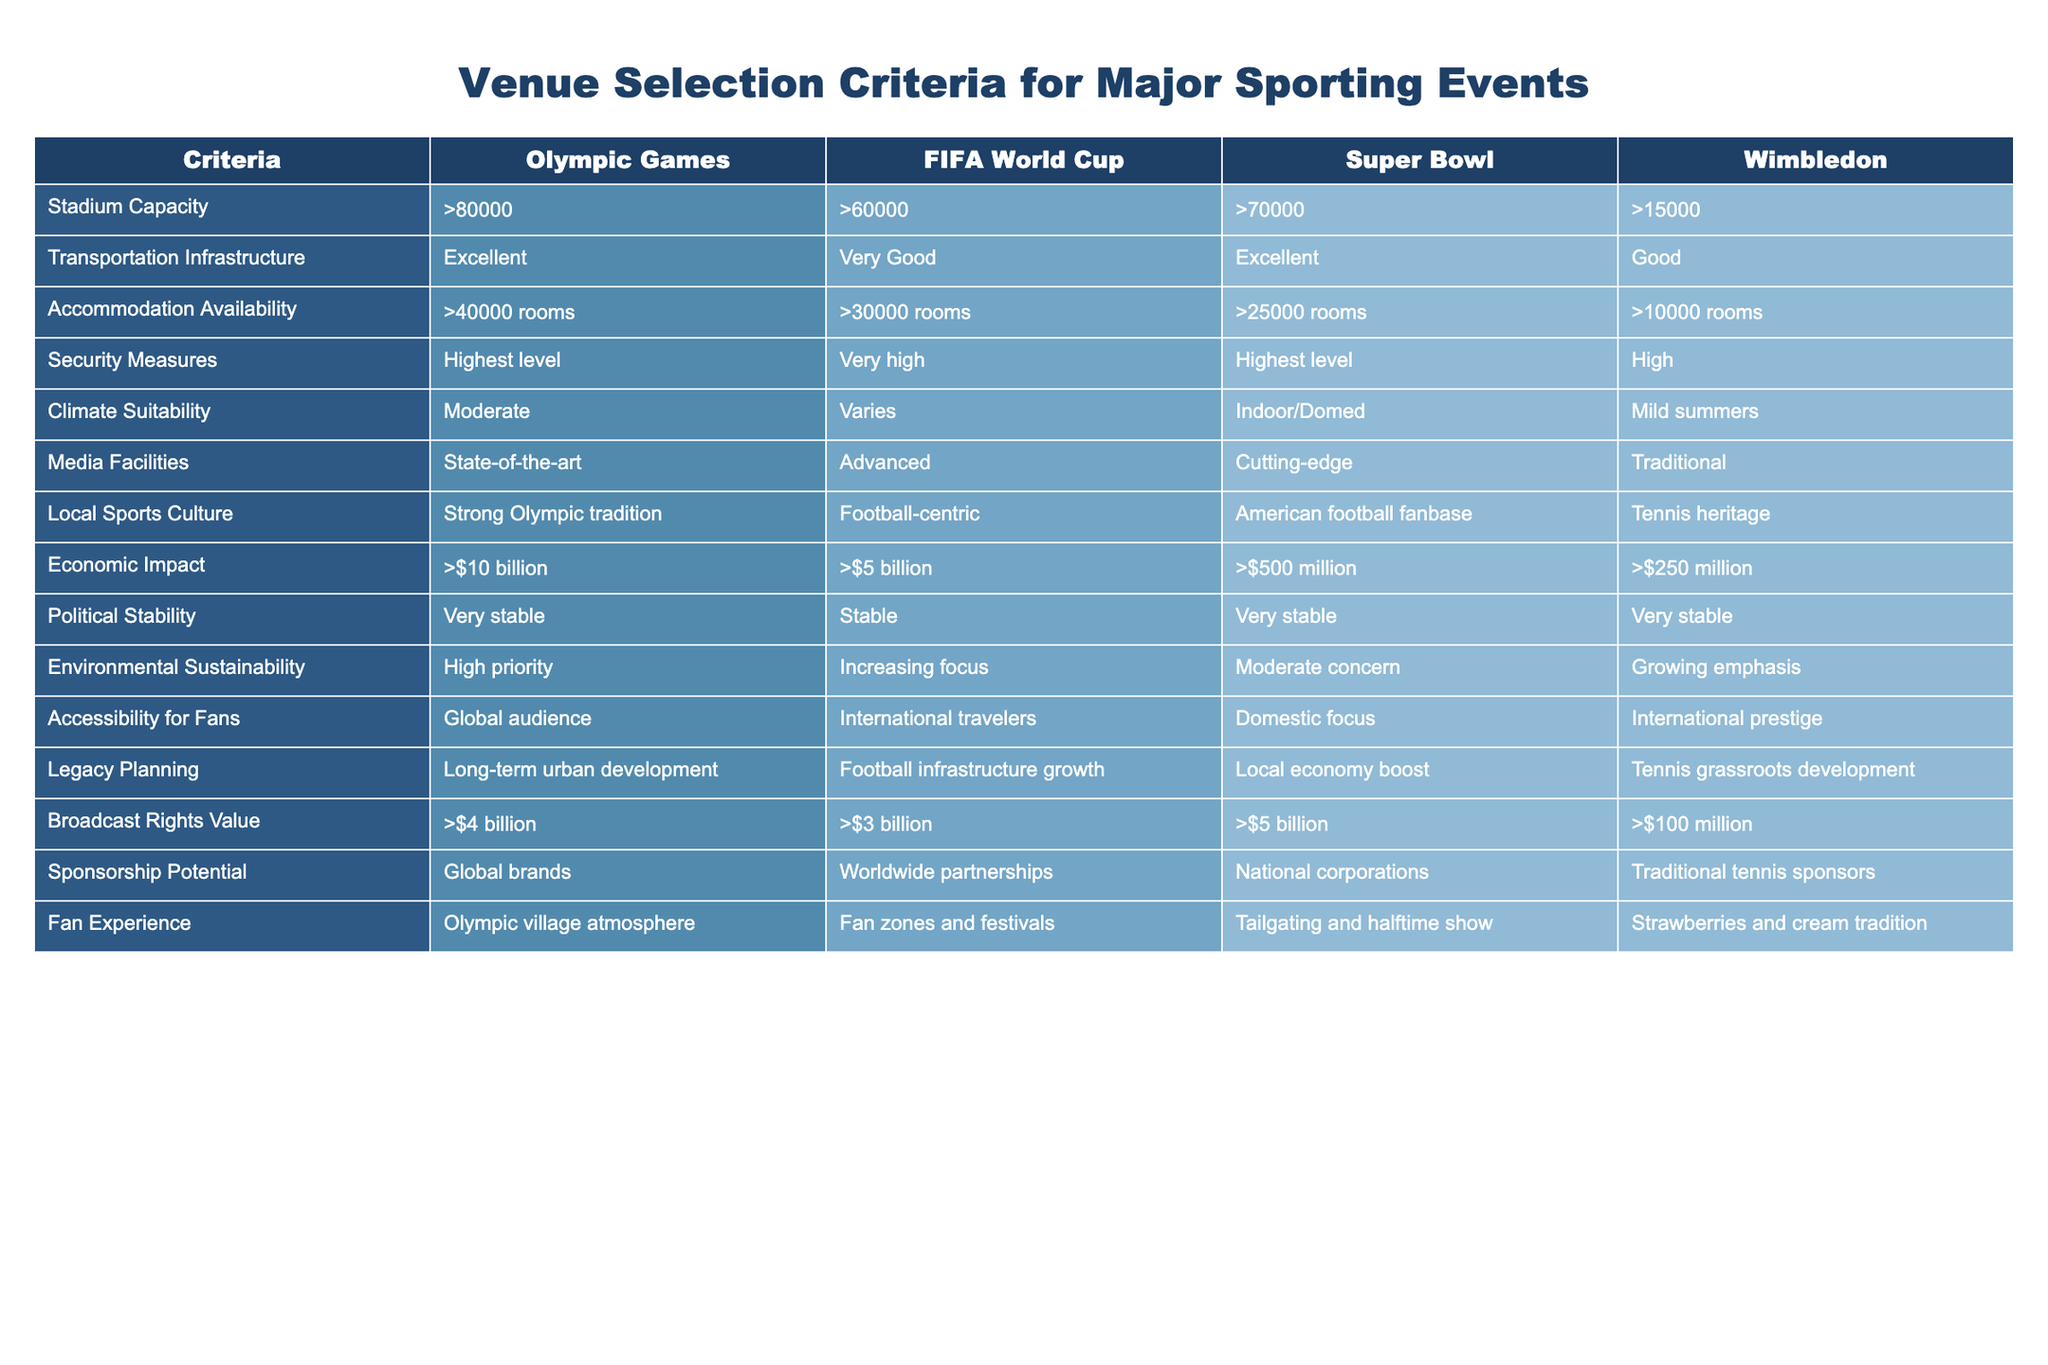What is the minimum stadium capacity required for the Olympic Games? The table specifies that the stadium capacity for the Olympic Games must be greater than 80,000.
Answer: >80000 Which event has the highest economic impact? According to the table, the Olympic Games have an economic impact exceeding 10 billion dollars, which is greater than the other events listed.
Answer: >$10 billion Is the Super Bowl classified as having excellent transportation infrastructure? The table shows that the Super Bowl has excellent transportation infrastructure, but it actually states "Excellent" for both the Olympic Games and Super Bowl. Therefore, the statement is true.
Answer: Yes What is the total number of rooms available for accommodation for both the FIFA World Cup and the Super Bowl combined? The FIFA World Cup offers more than 30,000 rooms, and the Super Bowl provides over 25,000 rooms. Adding these gives 30,000 + 25,000 = 55,000 rooms.
Answer: >55000 rooms Does Wimbledon have the strongest local sports culture compared to the other events? The table indicates that Wimbledon has a tennis heritage, which is significant, but the Olympic Games is characterized by a "Strong Olympic tradition." Thus, Wimbledon does not have the strongest local sports culture.
Answer: No What type of climate is most suitable for the FIFA World Cup? The table states that the climate suitability for the FIFA World Cup varies, indicating it does not have a specific climate classification compared to the other events listed.
Answer: Varies Are the sponsorship potentials for the Super Bowl and Wimbledon equal? The table shows that the Super Bowl has national corporation sponsorship potential, while Wimbledon has traditional tennis sponsors, which are different. Therefore, they are not equal.
Answer: No What is the difference in the broadcast rights value between the Olympic Games and Wimbledon? The table lists the broadcast rights value for the Olympic Games at more than 4 billion dollars and for Wimbledon at more than 100 million dollars. The difference is 4 billion - 100 million = 3.9 billion.
Answer: $3.9 billion Which event places the highest emphasis on environmental sustainability? From the table, it is evident that the Olympic Games have a high priority for environmental sustainability, which is higher than the "increasing focus" for the FIFA World Cup and "growing emphasis" for Wimbledon. Thus, the Olympic Games place the highest emphasis.
Answer: Olympic Games 